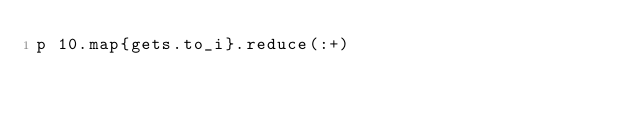Convert code to text. <code><loc_0><loc_0><loc_500><loc_500><_Ruby_>p 10.map{gets.to_i}.reduce(:+)</code> 